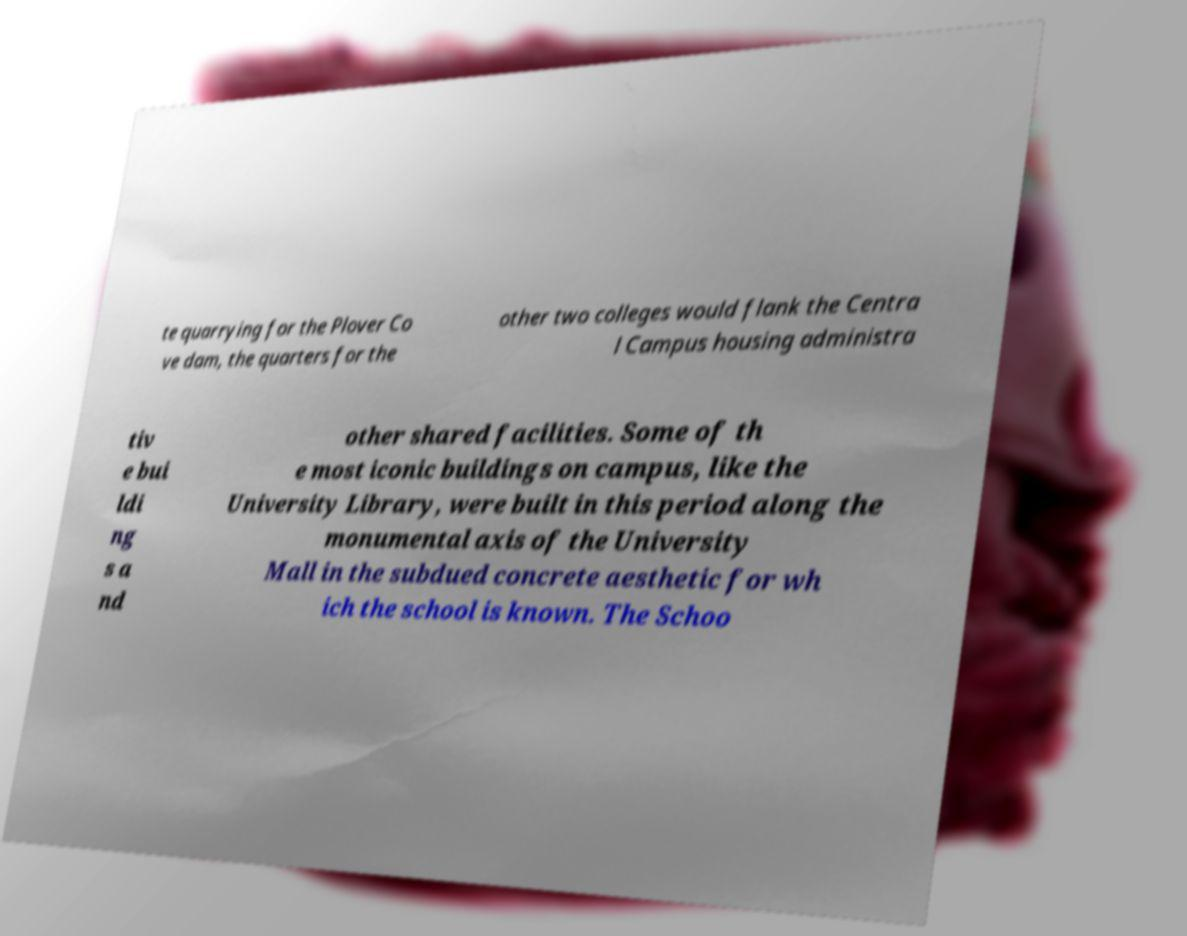Could you extract and type out the text from this image? te quarrying for the Plover Co ve dam, the quarters for the other two colleges would flank the Centra l Campus housing administra tiv e bui ldi ng s a nd other shared facilities. Some of th e most iconic buildings on campus, like the University Library, were built in this period along the monumental axis of the University Mall in the subdued concrete aesthetic for wh ich the school is known. The Schoo 